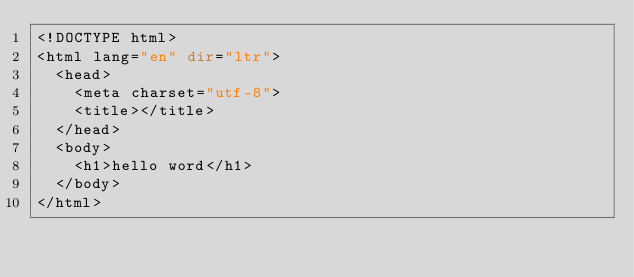<code> <loc_0><loc_0><loc_500><loc_500><_PHP_><!DOCTYPE html>
<html lang="en" dir="ltr">
  <head>
    <meta charset="utf-8">
    <title></title>
  </head>
  <body>
    <h1>hello word</h1>
  </body>
</html>
</code> 